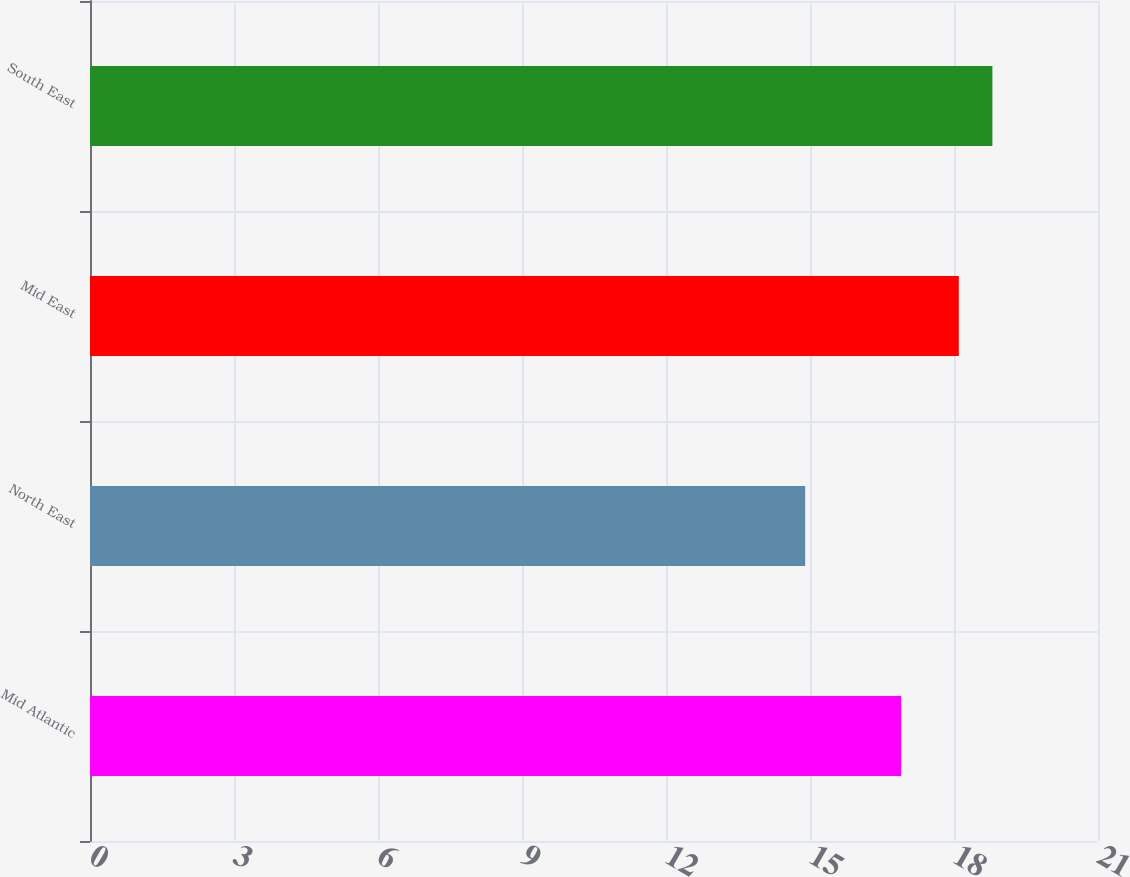Convert chart. <chart><loc_0><loc_0><loc_500><loc_500><bar_chart><fcel>Mid Atlantic<fcel>North East<fcel>Mid East<fcel>South East<nl><fcel>16.9<fcel>14.9<fcel>18.1<fcel>18.8<nl></chart> 